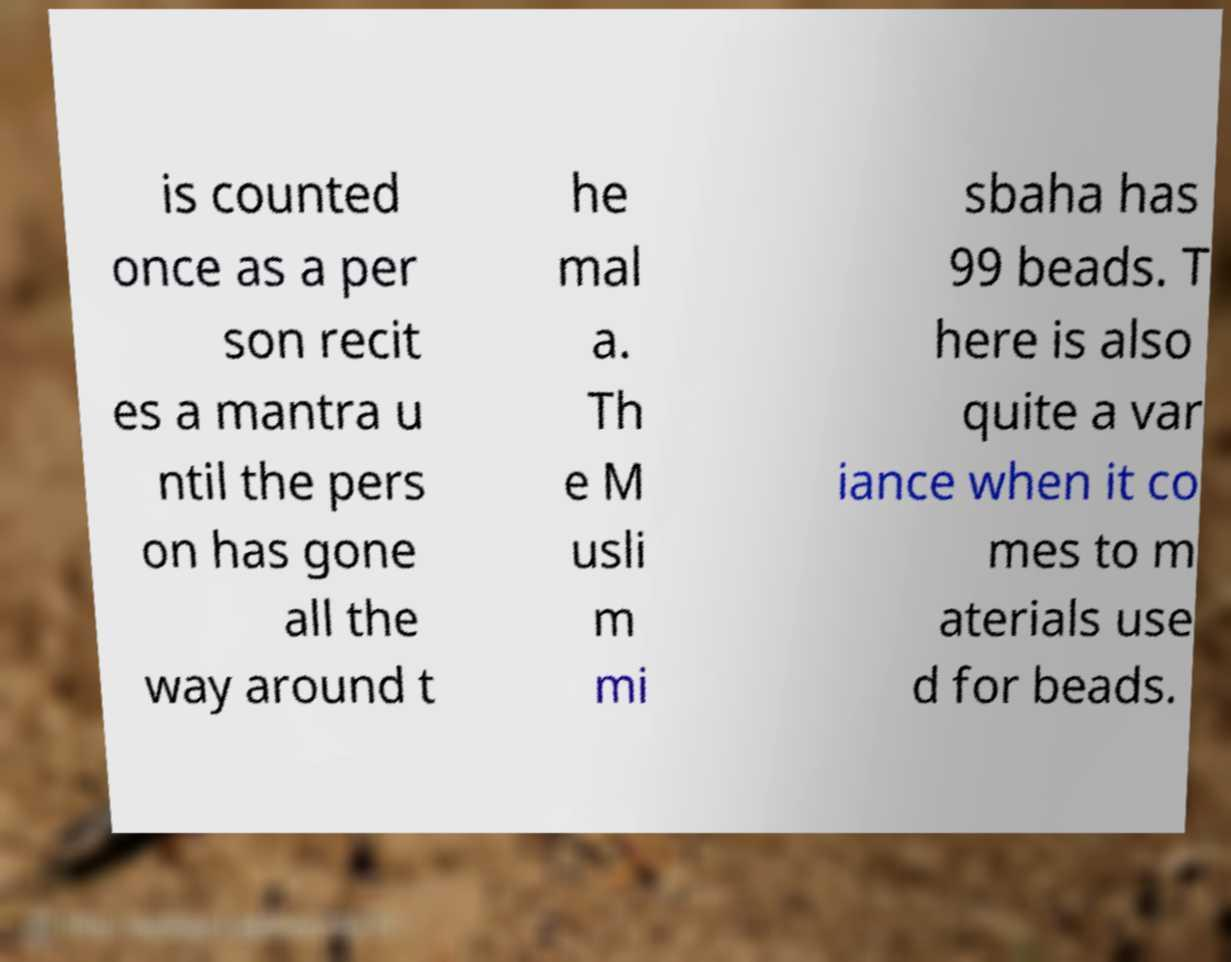Please identify and transcribe the text found in this image. is counted once as a per son recit es a mantra u ntil the pers on has gone all the way around t he mal a. Th e M usli m mi sbaha has 99 beads. T here is also quite a var iance when it co mes to m aterials use d for beads. 